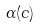<formula> <loc_0><loc_0><loc_500><loc_500>\alpha ( c )</formula> 